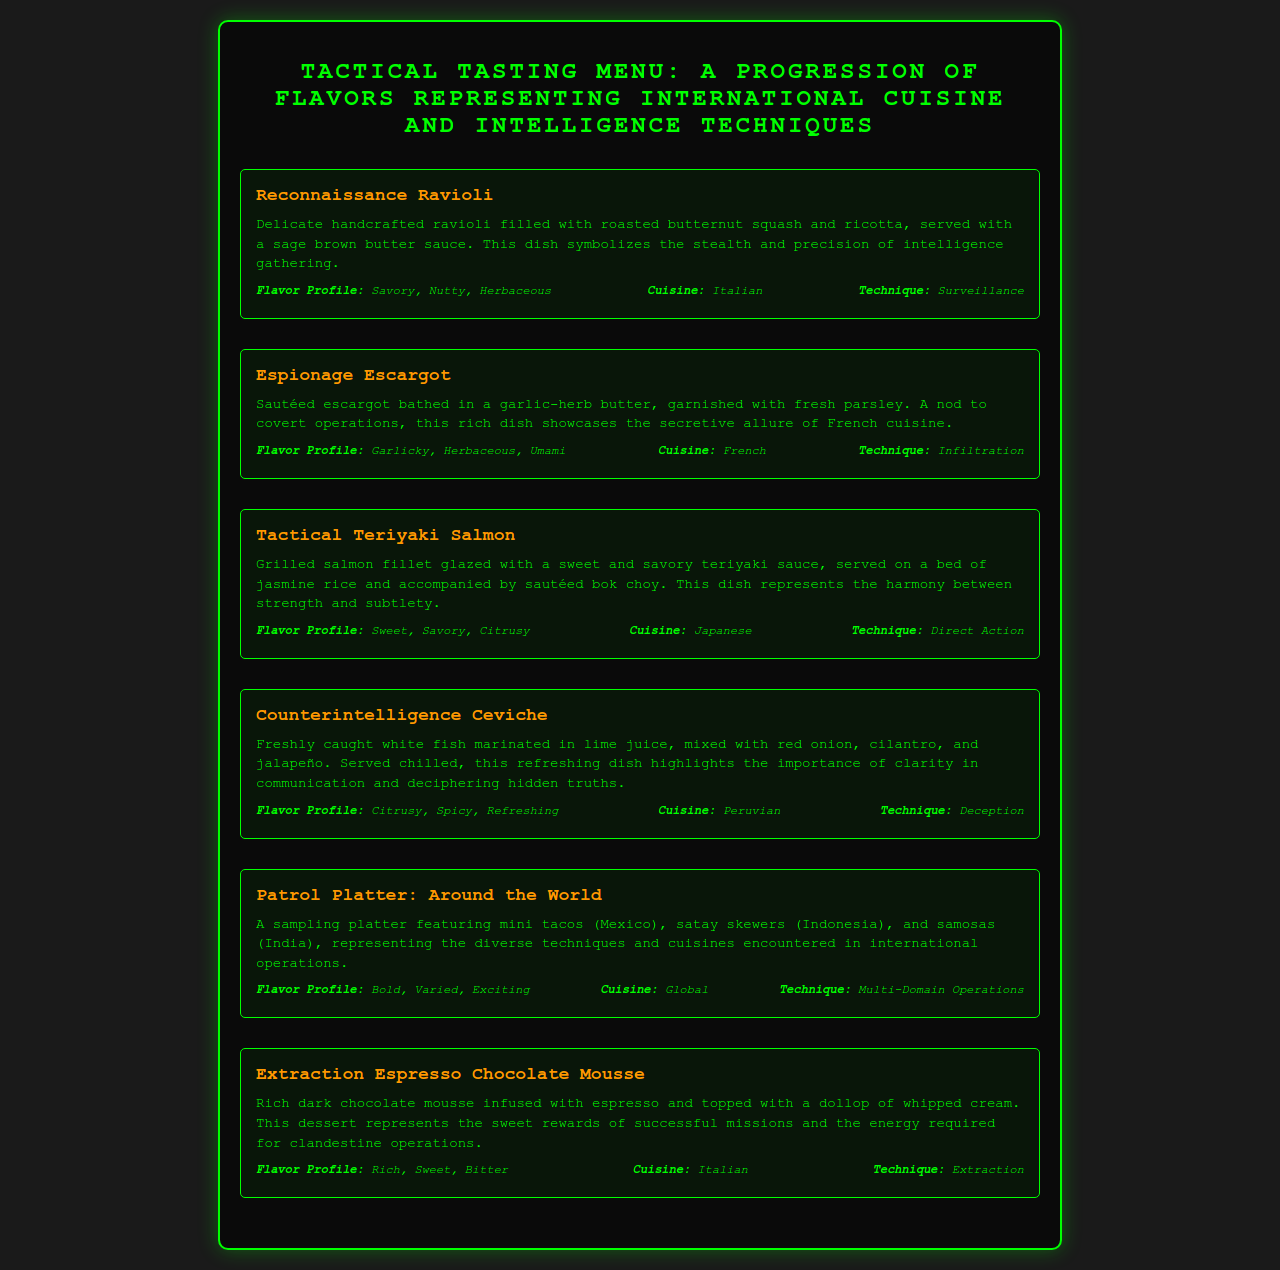What is the first course in the menu? The first course listed in the menu is "Reconnaissance Ravioli".
Answer: Reconnaissance Ravioli How many courses are featured in the Tactical Tasting Menu? There are six courses presented in the Tactical Tasting Menu.
Answer: Six What flavor profiles are associated with Tactical Teriyaki Salmon? The flavor profiles for Tactical Teriyaki Salmon are Sweet, Savory, and Citrusy.
Answer: Sweet, Savory, Citrusy Which dish represents the concept of "Extraction"? The dish that represents the concept of "Extraction" is "Extraction Espresso Chocolate Mousse".
Answer: Extraction Espresso Chocolate Mousse What is the cuisine inspiration for Counterintelligence Ceviche? The cuisine inspiration for Counterintelligence Ceviche is Peruvian.
Answer: Peruvian Which course includes a variety of global cuisines? The course that includes a variety of global cuisines is called "Patrol Platter: Around the World".
Answer: Patrol Platter: Around the World What technique does the Espionage Escargot symbolize? The technique symbolized by the Espionage Escargot is "Infiltration".
Answer: Infiltration What is the flavor profile of Espionage Escargot? The flavor profile of Espionage Escargot is Garlicky, Herbaceous, and Umami.
Answer: Garlicky, Herbaceous, Umami What is the main ingredient in the Reconnaissance Ravioli? The main ingredients in Reconnaissance Ravioli are roasted butternut squash and ricotta.
Answer: Roasted butternut squash and ricotta 